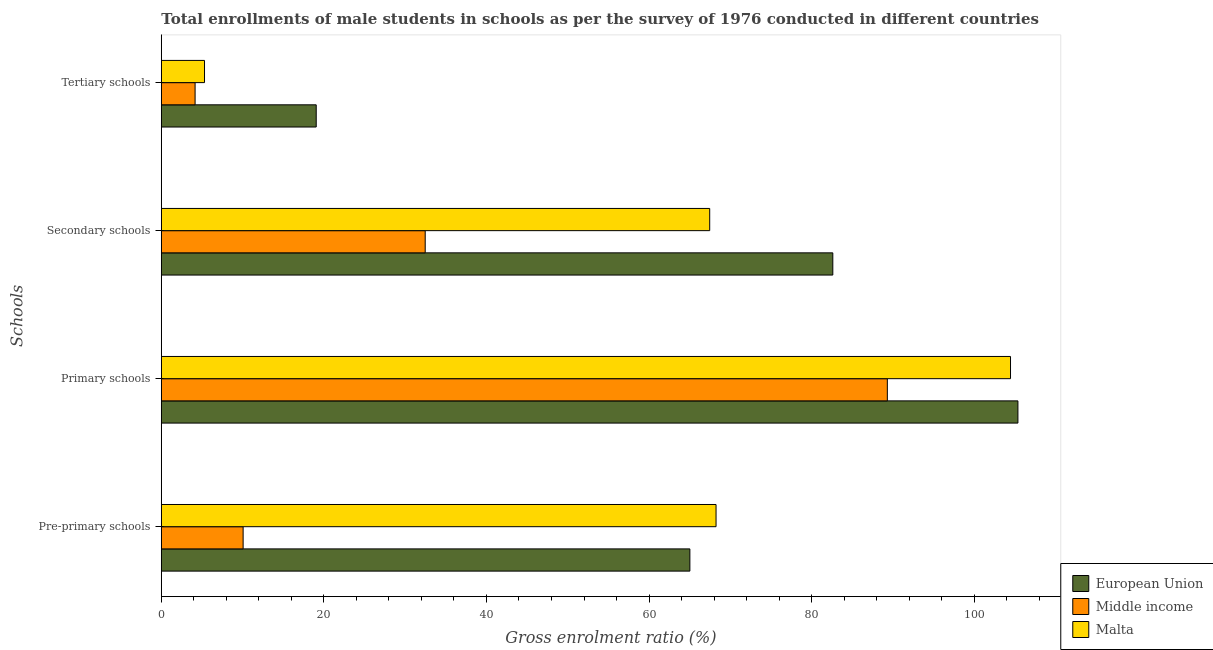Are the number of bars per tick equal to the number of legend labels?
Provide a succinct answer. Yes. What is the label of the 1st group of bars from the top?
Your answer should be compact. Tertiary schools. What is the gross enrolment ratio(male) in primary schools in Middle income?
Your answer should be very brief. 89.32. Across all countries, what is the maximum gross enrolment ratio(male) in tertiary schools?
Your answer should be very brief. 19.06. Across all countries, what is the minimum gross enrolment ratio(male) in primary schools?
Offer a very short reply. 89.32. In which country was the gross enrolment ratio(male) in secondary schools maximum?
Provide a short and direct response. European Union. What is the total gross enrolment ratio(male) in secondary schools in the graph?
Offer a very short reply. 182.54. What is the difference between the gross enrolment ratio(male) in pre-primary schools in European Union and that in Middle income?
Your answer should be compact. 54.96. What is the difference between the gross enrolment ratio(male) in primary schools in Middle income and the gross enrolment ratio(male) in pre-primary schools in Malta?
Provide a succinct answer. 21.07. What is the average gross enrolment ratio(male) in tertiary schools per country?
Your answer should be very brief. 9.51. What is the difference between the gross enrolment ratio(male) in primary schools and gross enrolment ratio(male) in secondary schools in European Union?
Offer a terse response. 22.77. In how many countries, is the gross enrolment ratio(male) in secondary schools greater than 20 %?
Give a very brief answer. 3. What is the ratio of the gross enrolment ratio(male) in pre-primary schools in Malta to that in European Union?
Keep it short and to the point. 1.05. Is the gross enrolment ratio(male) in secondary schools in Middle income less than that in Malta?
Your answer should be very brief. Yes. What is the difference between the highest and the second highest gross enrolment ratio(male) in secondary schools?
Your answer should be very brief. 15.15. What is the difference between the highest and the lowest gross enrolment ratio(male) in primary schools?
Provide a succinct answer. 16.07. In how many countries, is the gross enrolment ratio(male) in secondary schools greater than the average gross enrolment ratio(male) in secondary schools taken over all countries?
Offer a terse response. 2. Is the sum of the gross enrolment ratio(male) in primary schools in European Union and Middle income greater than the maximum gross enrolment ratio(male) in tertiary schools across all countries?
Provide a short and direct response. Yes. What does the 1st bar from the top in Tertiary schools represents?
Keep it short and to the point. Malta. What does the 3rd bar from the bottom in Primary schools represents?
Provide a short and direct response. Malta. Is it the case that in every country, the sum of the gross enrolment ratio(male) in pre-primary schools and gross enrolment ratio(male) in primary schools is greater than the gross enrolment ratio(male) in secondary schools?
Keep it short and to the point. Yes. How many bars are there?
Provide a succinct answer. 12. How many countries are there in the graph?
Your response must be concise. 3. What is the difference between two consecutive major ticks on the X-axis?
Provide a succinct answer. 20. Are the values on the major ticks of X-axis written in scientific E-notation?
Provide a succinct answer. No. Where does the legend appear in the graph?
Ensure brevity in your answer.  Bottom right. How many legend labels are there?
Offer a terse response. 3. How are the legend labels stacked?
Keep it short and to the point. Vertical. What is the title of the graph?
Make the answer very short. Total enrollments of male students in schools as per the survey of 1976 conducted in different countries. Does "Malawi" appear as one of the legend labels in the graph?
Offer a terse response. No. What is the label or title of the X-axis?
Provide a succinct answer. Gross enrolment ratio (%). What is the label or title of the Y-axis?
Provide a succinct answer. Schools. What is the Gross enrolment ratio (%) in European Union in Pre-primary schools?
Your answer should be very brief. 65.03. What is the Gross enrolment ratio (%) of Middle income in Pre-primary schools?
Your answer should be compact. 10.07. What is the Gross enrolment ratio (%) in Malta in Pre-primary schools?
Offer a terse response. 68.25. What is the Gross enrolment ratio (%) in European Union in Primary schools?
Offer a very short reply. 105.38. What is the Gross enrolment ratio (%) in Middle income in Primary schools?
Keep it short and to the point. 89.32. What is the Gross enrolment ratio (%) in Malta in Primary schools?
Your answer should be compact. 104.47. What is the Gross enrolment ratio (%) of European Union in Secondary schools?
Offer a very short reply. 82.61. What is the Gross enrolment ratio (%) of Middle income in Secondary schools?
Your answer should be compact. 32.46. What is the Gross enrolment ratio (%) of Malta in Secondary schools?
Give a very brief answer. 67.46. What is the Gross enrolment ratio (%) of European Union in Tertiary schools?
Keep it short and to the point. 19.06. What is the Gross enrolment ratio (%) in Middle income in Tertiary schools?
Provide a short and direct response. 4.15. What is the Gross enrolment ratio (%) in Malta in Tertiary schools?
Your response must be concise. 5.32. Across all Schools, what is the maximum Gross enrolment ratio (%) in European Union?
Your answer should be compact. 105.38. Across all Schools, what is the maximum Gross enrolment ratio (%) of Middle income?
Keep it short and to the point. 89.32. Across all Schools, what is the maximum Gross enrolment ratio (%) in Malta?
Ensure brevity in your answer.  104.47. Across all Schools, what is the minimum Gross enrolment ratio (%) of European Union?
Provide a short and direct response. 19.06. Across all Schools, what is the minimum Gross enrolment ratio (%) in Middle income?
Your answer should be compact. 4.15. Across all Schools, what is the minimum Gross enrolment ratio (%) of Malta?
Make the answer very short. 5.32. What is the total Gross enrolment ratio (%) in European Union in the graph?
Provide a succinct answer. 272.08. What is the total Gross enrolment ratio (%) in Middle income in the graph?
Make the answer very short. 136. What is the total Gross enrolment ratio (%) in Malta in the graph?
Offer a terse response. 245.49. What is the difference between the Gross enrolment ratio (%) of European Union in Pre-primary schools and that in Primary schools?
Your answer should be compact. -40.36. What is the difference between the Gross enrolment ratio (%) in Middle income in Pre-primary schools and that in Primary schools?
Your answer should be very brief. -79.25. What is the difference between the Gross enrolment ratio (%) of Malta in Pre-primary schools and that in Primary schools?
Give a very brief answer. -36.23. What is the difference between the Gross enrolment ratio (%) in European Union in Pre-primary schools and that in Secondary schools?
Give a very brief answer. -17.59. What is the difference between the Gross enrolment ratio (%) in Middle income in Pre-primary schools and that in Secondary schools?
Offer a terse response. -22.4. What is the difference between the Gross enrolment ratio (%) of Malta in Pre-primary schools and that in Secondary schools?
Make the answer very short. 0.78. What is the difference between the Gross enrolment ratio (%) in European Union in Pre-primary schools and that in Tertiary schools?
Make the answer very short. 45.97. What is the difference between the Gross enrolment ratio (%) in Middle income in Pre-primary schools and that in Tertiary schools?
Offer a terse response. 5.91. What is the difference between the Gross enrolment ratio (%) of Malta in Pre-primary schools and that in Tertiary schools?
Make the answer very short. 62.93. What is the difference between the Gross enrolment ratio (%) of European Union in Primary schools and that in Secondary schools?
Give a very brief answer. 22.77. What is the difference between the Gross enrolment ratio (%) of Middle income in Primary schools and that in Secondary schools?
Offer a very short reply. 56.85. What is the difference between the Gross enrolment ratio (%) in Malta in Primary schools and that in Secondary schools?
Offer a very short reply. 37.01. What is the difference between the Gross enrolment ratio (%) of European Union in Primary schools and that in Tertiary schools?
Provide a succinct answer. 86.33. What is the difference between the Gross enrolment ratio (%) in Middle income in Primary schools and that in Tertiary schools?
Provide a succinct answer. 85.16. What is the difference between the Gross enrolment ratio (%) of Malta in Primary schools and that in Tertiary schools?
Give a very brief answer. 99.16. What is the difference between the Gross enrolment ratio (%) in European Union in Secondary schools and that in Tertiary schools?
Offer a terse response. 63.55. What is the difference between the Gross enrolment ratio (%) in Middle income in Secondary schools and that in Tertiary schools?
Ensure brevity in your answer.  28.31. What is the difference between the Gross enrolment ratio (%) in Malta in Secondary schools and that in Tertiary schools?
Your answer should be very brief. 62.15. What is the difference between the Gross enrolment ratio (%) in European Union in Pre-primary schools and the Gross enrolment ratio (%) in Middle income in Primary schools?
Give a very brief answer. -24.29. What is the difference between the Gross enrolment ratio (%) of European Union in Pre-primary schools and the Gross enrolment ratio (%) of Malta in Primary schools?
Provide a short and direct response. -39.45. What is the difference between the Gross enrolment ratio (%) in Middle income in Pre-primary schools and the Gross enrolment ratio (%) in Malta in Primary schools?
Give a very brief answer. -94.41. What is the difference between the Gross enrolment ratio (%) in European Union in Pre-primary schools and the Gross enrolment ratio (%) in Middle income in Secondary schools?
Your answer should be very brief. 32.56. What is the difference between the Gross enrolment ratio (%) of European Union in Pre-primary schools and the Gross enrolment ratio (%) of Malta in Secondary schools?
Offer a very short reply. -2.44. What is the difference between the Gross enrolment ratio (%) of Middle income in Pre-primary schools and the Gross enrolment ratio (%) of Malta in Secondary schools?
Offer a very short reply. -57.4. What is the difference between the Gross enrolment ratio (%) of European Union in Pre-primary schools and the Gross enrolment ratio (%) of Middle income in Tertiary schools?
Offer a terse response. 60.87. What is the difference between the Gross enrolment ratio (%) of European Union in Pre-primary schools and the Gross enrolment ratio (%) of Malta in Tertiary schools?
Provide a succinct answer. 59.71. What is the difference between the Gross enrolment ratio (%) of Middle income in Pre-primary schools and the Gross enrolment ratio (%) of Malta in Tertiary schools?
Your response must be concise. 4.75. What is the difference between the Gross enrolment ratio (%) of European Union in Primary schools and the Gross enrolment ratio (%) of Middle income in Secondary schools?
Ensure brevity in your answer.  72.92. What is the difference between the Gross enrolment ratio (%) in European Union in Primary schools and the Gross enrolment ratio (%) in Malta in Secondary schools?
Ensure brevity in your answer.  37.92. What is the difference between the Gross enrolment ratio (%) of Middle income in Primary schools and the Gross enrolment ratio (%) of Malta in Secondary schools?
Ensure brevity in your answer.  21.85. What is the difference between the Gross enrolment ratio (%) in European Union in Primary schools and the Gross enrolment ratio (%) in Middle income in Tertiary schools?
Your answer should be compact. 101.23. What is the difference between the Gross enrolment ratio (%) in European Union in Primary schools and the Gross enrolment ratio (%) in Malta in Tertiary schools?
Offer a very short reply. 100.07. What is the difference between the Gross enrolment ratio (%) in Middle income in Primary schools and the Gross enrolment ratio (%) in Malta in Tertiary schools?
Give a very brief answer. 84. What is the difference between the Gross enrolment ratio (%) of European Union in Secondary schools and the Gross enrolment ratio (%) of Middle income in Tertiary schools?
Offer a terse response. 78.46. What is the difference between the Gross enrolment ratio (%) of European Union in Secondary schools and the Gross enrolment ratio (%) of Malta in Tertiary schools?
Keep it short and to the point. 77.3. What is the difference between the Gross enrolment ratio (%) of Middle income in Secondary schools and the Gross enrolment ratio (%) of Malta in Tertiary schools?
Provide a succinct answer. 27.15. What is the average Gross enrolment ratio (%) of European Union per Schools?
Your response must be concise. 68.02. What is the average Gross enrolment ratio (%) of Middle income per Schools?
Offer a very short reply. 34. What is the average Gross enrolment ratio (%) of Malta per Schools?
Offer a very short reply. 61.37. What is the difference between the Gross enrolment ratio (%) of European Union and Gross enrolment ratio (%) of Middle income in Pre-primary schools?
Give a very brief answer. 54.96. What is the difference between the Gross enrolment ratio (%) in European Union and Gross enrolment ratio (%) in Malta in Pre-primary schools?
Your answer should be compact. -3.22. What is the difference between the Gross enrolment ratio (%) in Middle income and Gross enrolment ratio (%) in Malta in Pre-primary schools?
Offer a terse response. -58.18. What is the difference between the Gross enrolment ratio (%) of European Union and Gross enrolment ratio (%) of Middle income in Primary schools?
Your response must be concise. 16.07. What is the difference between the Gross enrolment ratio (%) of European Union and Gross enrolment ratio (%) of Malta in Primary schools?
Your answer should be very brief. 0.91. What is the difference between the Gross enrolment ratio (%) in Middle income and Gross enrolment ratio (%) in Malta in Primary schools?
Your answer should be very brief. -15.15. What is the difference between the Gross enrolment ratio (%) in European Union and Gross enrolment ratio (%) in Middle income in Secondary schools?
Provide a succinct answer. 50.15. What is the difference between the Gross enrolment ratio (%) in European Union and Gross enrolment ratio (%) in Malta in Secondary schools?
Keep it short and to the point. 15.15. What is the difference between the Gross enrolment ratio (%) of Middle income and Gross enrolment ratio (%) of Malta in Secondary schools?
Ensure brevity in your answer.  -35. What is the difference between the Gross enrolment ratio (%) in European Union and Gross enrolment ratio (%) in Middle income in Tertiary schools?
Ensure brevity in your answer.  14.9. What is the difference between the Gross enrolment ratio (%) of European Union and Gross enrolment ratio (%) of Malta in Tertiary schools?
Your answer should be very brief. 13.74. What is the difference between the Gross enrolment ratio (%) in Middle income and Gross enrolment ratio (%) in Malta in Tertiary schools?
Offer a terse response. -1.16. What is the ratio of the Gross enrolment ratio (%) in European Union in Pre-primary schools to that in Primary schools?
Keep it short and to the point. 0.62. What is the ratio of the Gross enrolment ratio (%) of Middle income in Pre-primary schools to that in Primary schools?
Provide a short and direct response. 0.11. What is the ratio of the Gross enrolment ratio (%) in Malta in Pre-primary schools to that in Primary schools?
Provide a short and direct response. 0.65. What is the ratio of the Gross enrolment ratio (%) in European Union in Pre-primary schools to that in Secondary schools?
Offer a terse response. 0.79. What is the ratio of the Gross enrolment ratio (%) of Middle income in Pre-primary schools to that in Secondary schools?
Your answer should be compact. 0.31. What is the ratio of the Gross enrolment ratio (%) of Malta in Pre-primary schools to that in Secondary schools?
Provide a short and direct response. 1.01. What is the ratio of the Gross enrolment ratio (%) in European Union in Pre-primary schools to that in Tertiary schools?
Ensure brevity in your answer.  3.41. What is the ratio of the Gross enrolment ratio (%) in Middle income in Pre-primary schools to that in Tertiary schools?
Provide a succinct answer. 2.42. What is the ratio of the Gross enrolment ratio (%) in Malta in Pre-primary schools to that in Tertiary schools?
Provide a succinct answer. 12.84. What is the ratio of the Gross enrolment ratio (%) of European Union in Primary schools to that in Secondary schools?
Ensure brevity in your answer.  1.28. What is the ratio of the Gross enrolment ratio (%) in Middle income in Primary schools to that in Secondary schools?
Offer a very short reply. 2.75. What is the ratio of the Gross enrolment ratio (%) in Malta in Primary schools to that in Secondary schools?
Offer a terse response. 1.55. What is the ratio of the Gross enrolment ratio (%) in European Union in Primary schools to that in Tertiary schools?
Keep it short and to the point. 5.53. What is the ratio of the Gross enrolment ratio (%) in Middle income in Primary schools to that in Tertiary schools?
Ensure brevity in your answer.  21.5. What is the ratio of the Gross enrolment ratio (%) in Malta in Primary schools to that in Tertiary schools?
Provide a short and direct response. 19.66. What is the ratio of the Gross enrolment ratio (%) of European Union in Secondary schools to that in Tertiary schools?
Your response must be concise. 4.33. What is the ratio of the Gross enrolment ratio (%) in Middle income in Secondary schools to that in Tertiary schools?
Provide a short and direct response. 7.81. What is the ratio of the Gross enrolment ratio (%) of Malta in Secondary schools to that in Tertiary schools?
Keep it short and to the point. 12.69. What is the difference between the highest and the second highest Gross enrolment ratio (%) of European Union?
Provide a succinct answer. 22.77. What is the difference between the highest and the second highest Gross enrolment ratio (%) of Middle income?
Your answer should be compact. 56.85. What is the difference between the highest and the second highest Gross enrolment ratio (%) of Malta?
Provide a short and direct response. 36.23. What is the difference between the highest and the lowest Gross enrolment ratio (%) in European Union?
Give a very brief answer. 86.33. What is the difference between the highest and the lowest Gross enrolment ratio (%) in Middle income?
Your response must be concise. 85.16. What is the difference between the highest and the lowest Gross enrolment ratio (%) in Malta?
Keep it short and to the point. 99.16. 